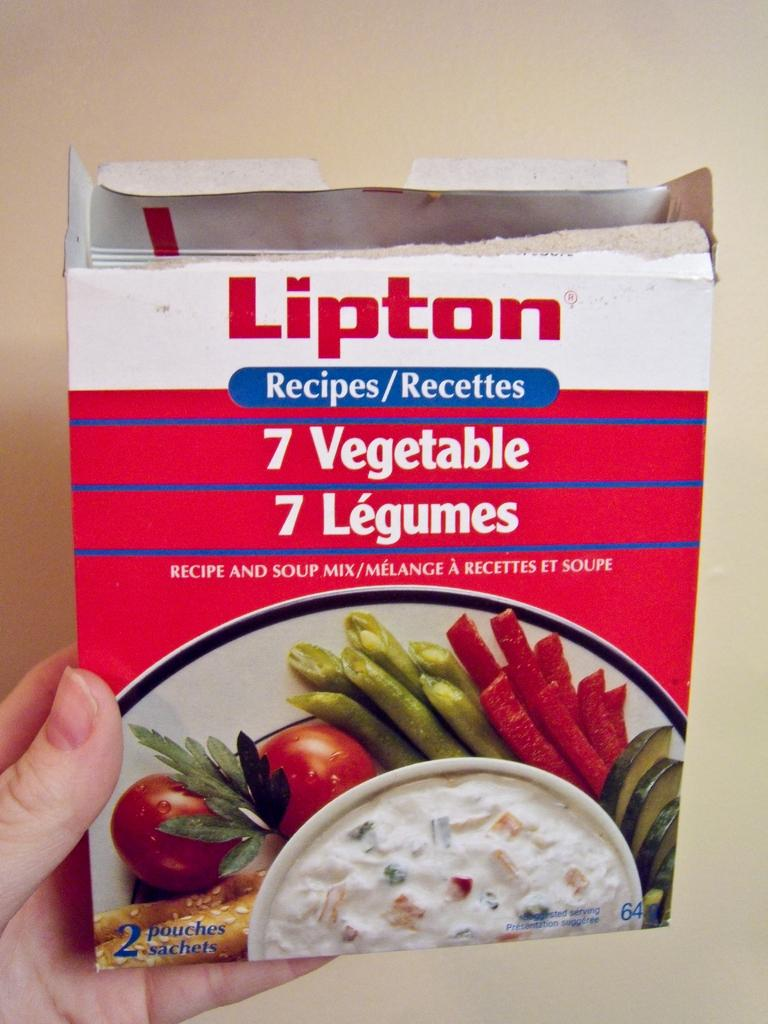Who or what is present in the image? There is a person in the image. What is the person holding in the image? The person is holding a box. What can be seen in the background of the image? There is a wall in the background of the image. What flavor of ice cream does the person in the image prefer? There is no information about ice cream or the person's preferences in the image. 